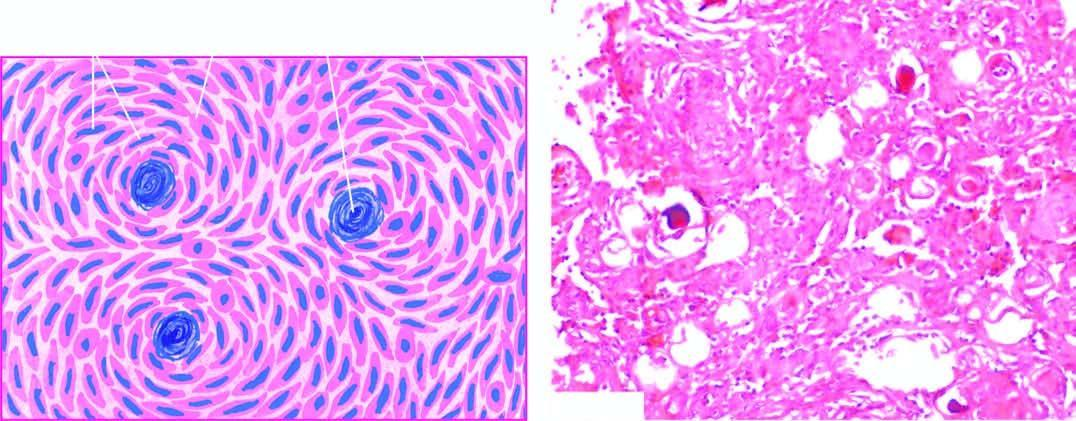do a gaucher cell in bone marrow contain psammoma bodies?
Answer the question using a single word or phrase. No 